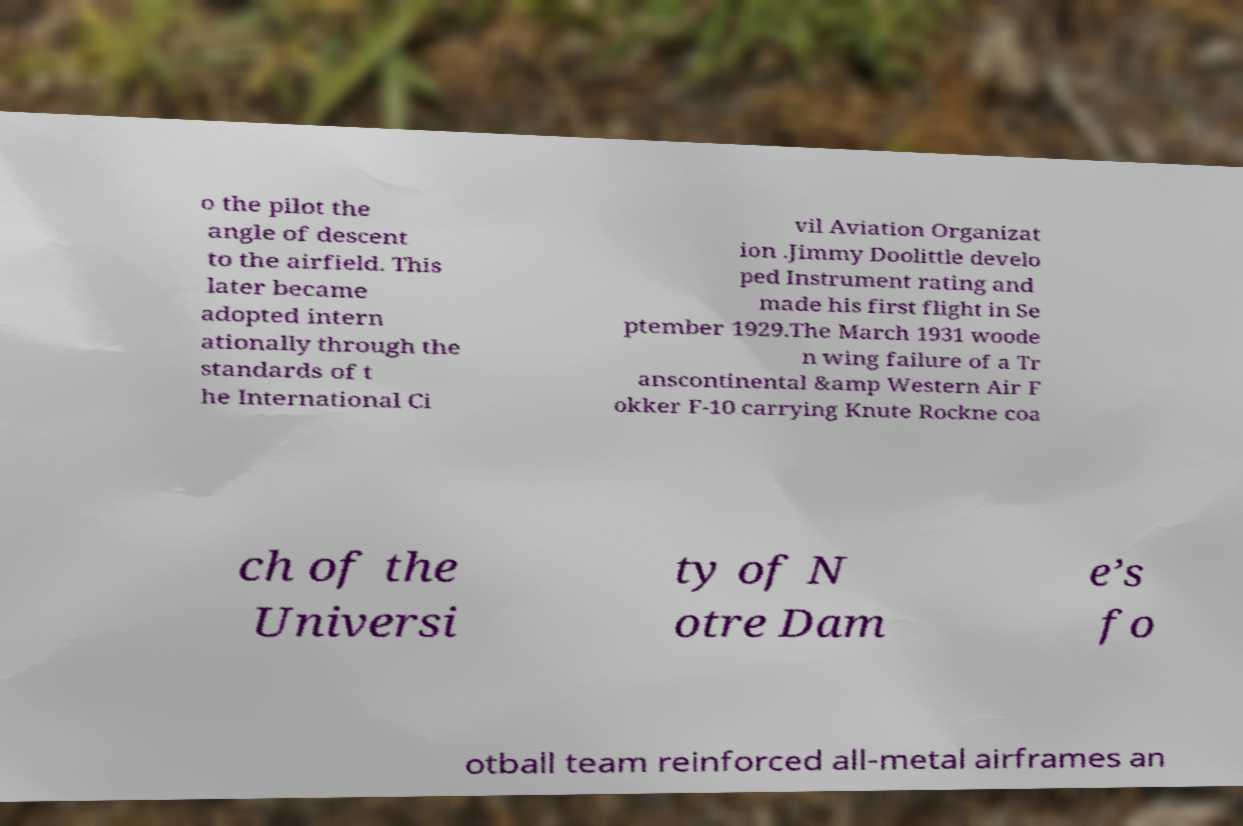What messages or text are displayed in this image? I need them in a readable, typed format. o the pilot the angle of descent to the airfield. This later became adopted intern ationally through the standards of t he International Ci vil Aviation Organizat ion .Jimmy Doolittle develo ped Instrument rating and made his first flight in Se ptember 1929.The March 1931 woode n wing failure of a Tr anscontinental &amp Western Air F okker F-10 carrying Knute Rockne coa ch of the Universi ty of N otre Dam e’s fo otball team reinforced all-metal airframes an 